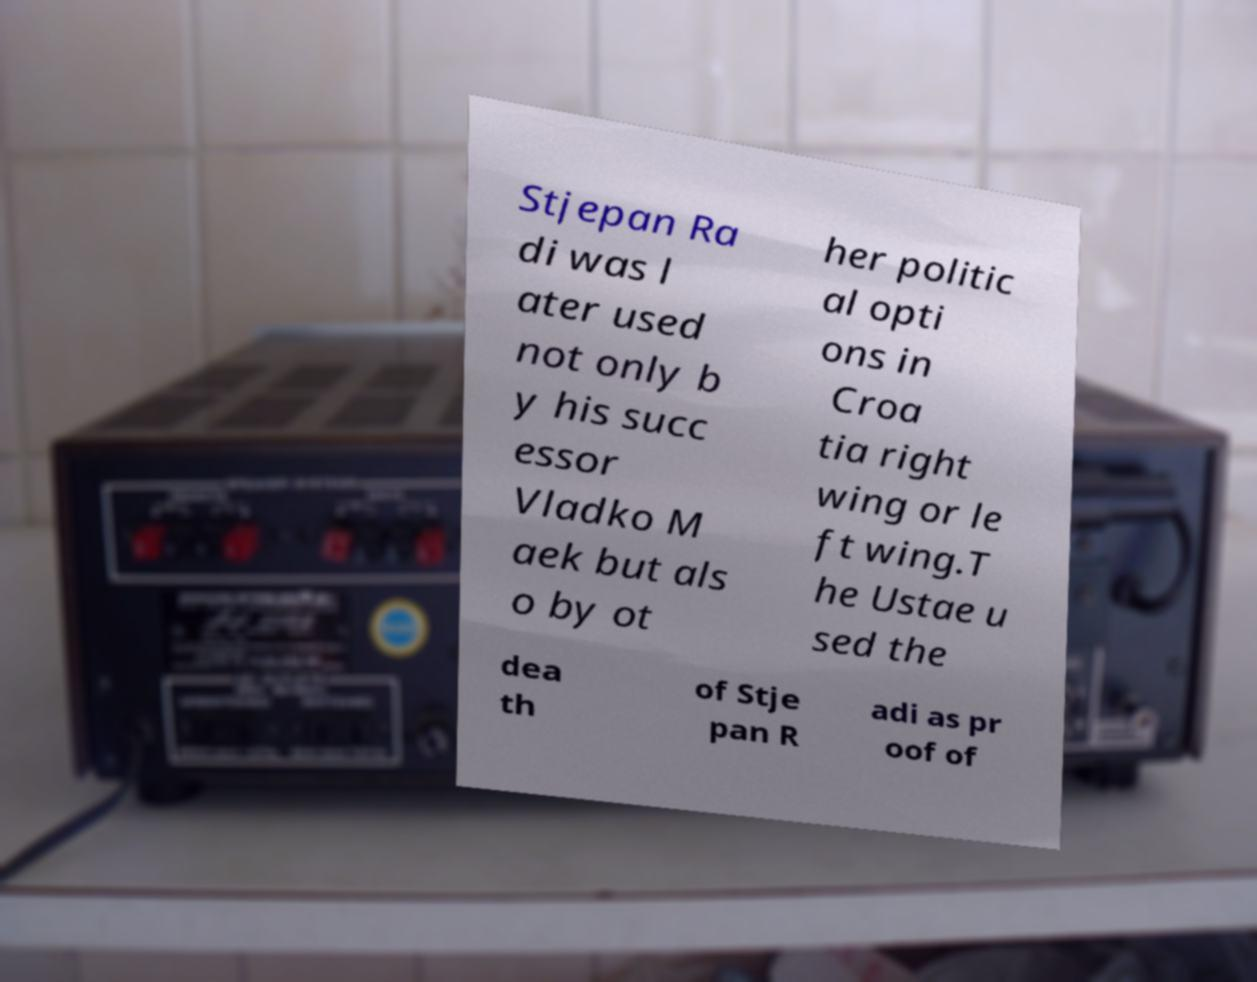Please read and relay the text visible in this image. What does it say? Stjepan Ra di was l ater used not only b y his succ essor Vladko M aek but als o by ot her politic al opti ons in Croa tia right wing or le ft wing.T he Ustae u sed the dea th of Stje pan R adi as pr oof of 